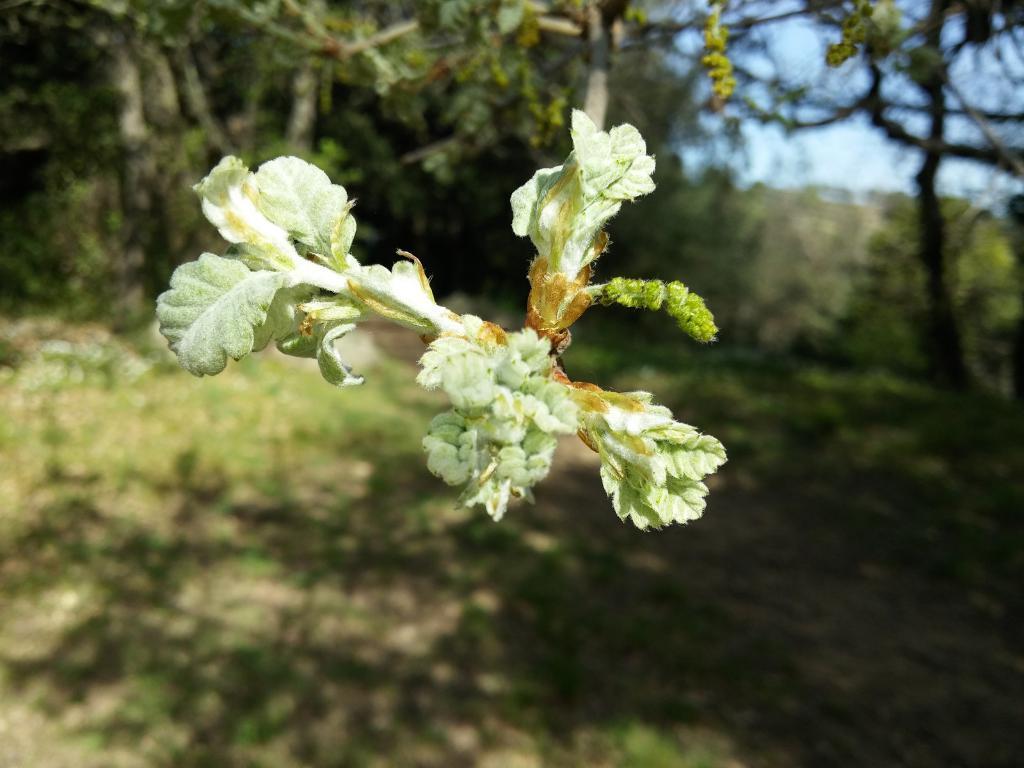In one or two sentences, can you explain what this image depicts? In this picture there are flowers on the tree. At the back there are trees. At the top there is sky. At the bottom there is grass and there is a shadow of the tree on the grass. 